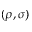<formula> <loc_0><loc_0><loc_500><loc_500>( \rho , \sigma )</formula> 